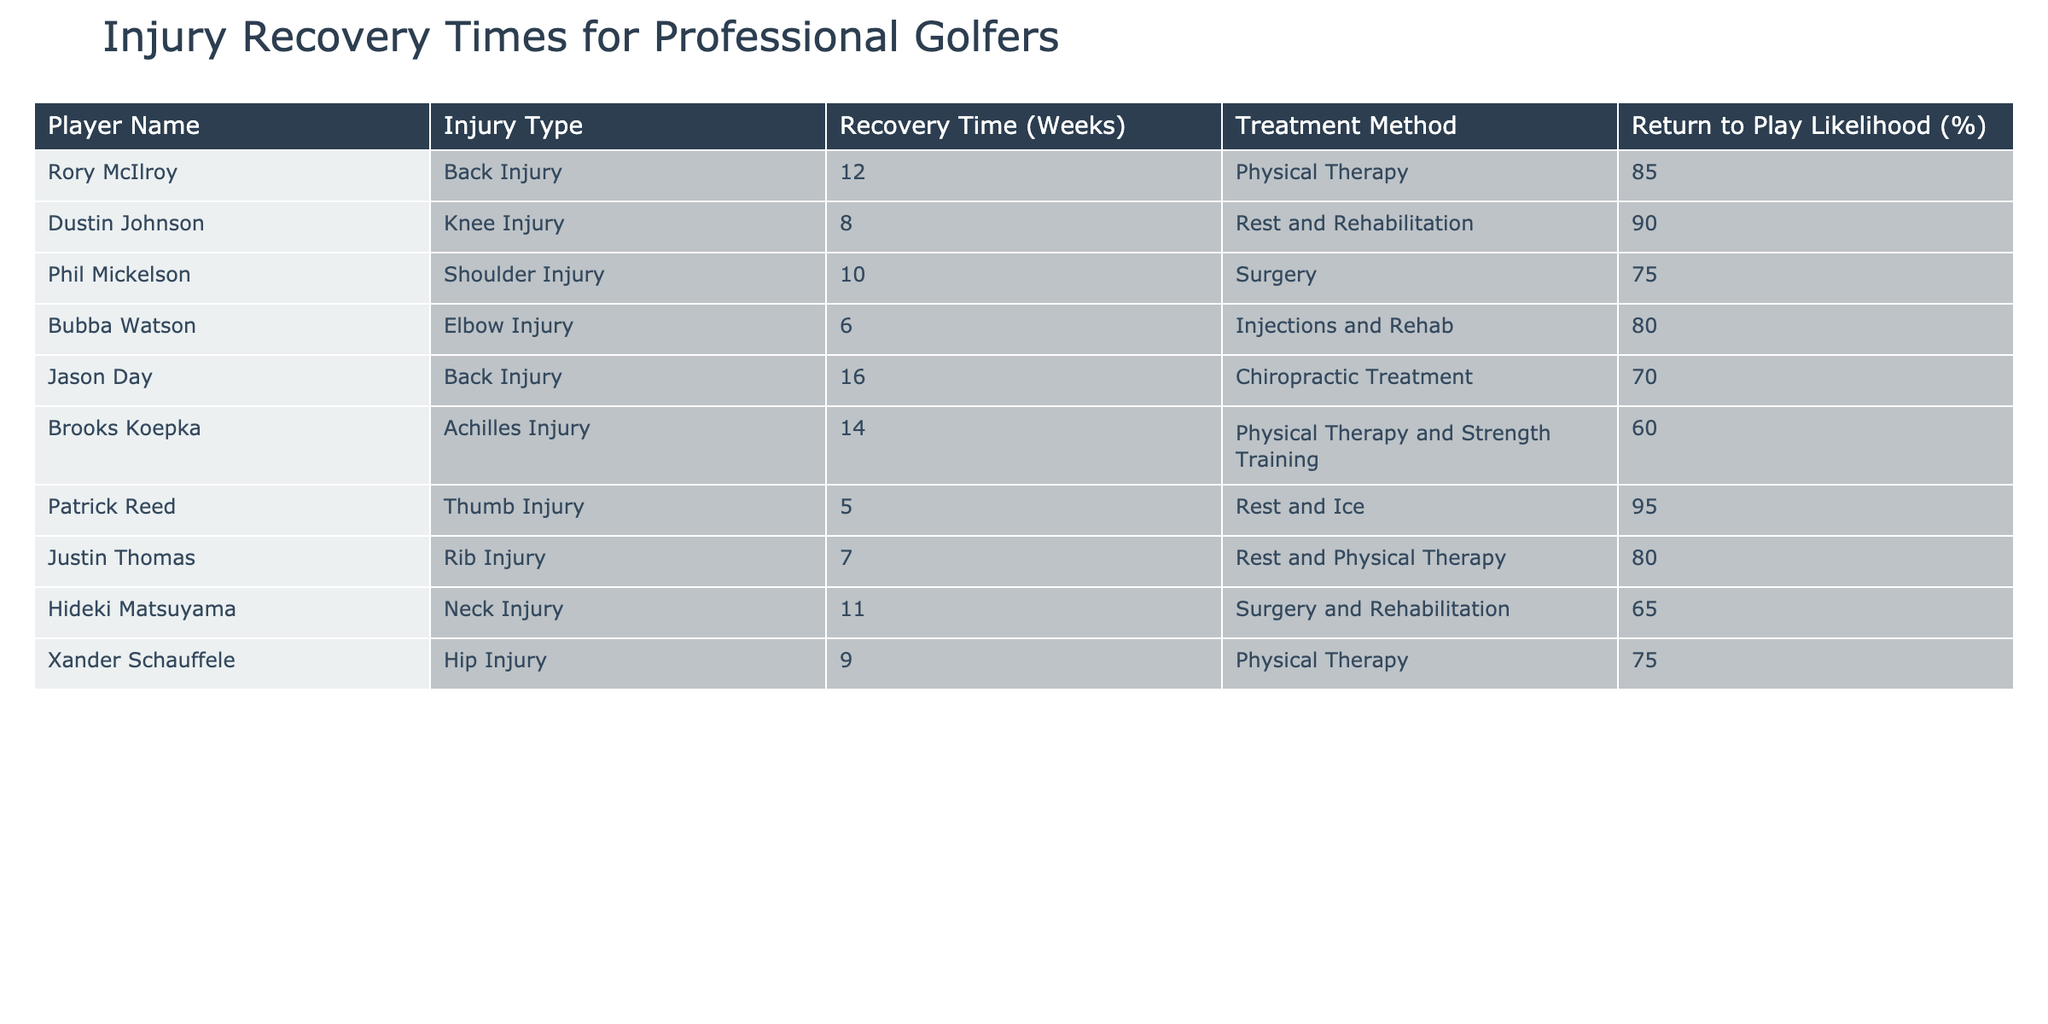What is the recovery time for Rory McIlroy? The table shows that Rory McIlroy has a recovery time of 12 weeks due to a back injury.
Answer: 12 weeks Which injury had the shortest recovery time? By comparing all recovery times listed in the table, the shortest recovery time is 5 weeks for Patrick Reed's thumb injury.
Answer: 5 weeks What is the likelihood of return to play for Jason Day? According to the table, Jason Day has a return to play likelihood of 70%.
Answer: 70% How many players implemented surgery as a treatment method? There are three players who underwent surgery: Phil Mickelson, Hideki Matsuyama, and one more player with a shoulder injury. Counting them gives us a total of 2.
Answer: 2 players What is the average recovery time for the players listed? First, we sum all the recovery times: 12 + 8 + 10 + 6 + 16 + 14 + 5 + 7 + 11 + 9 = 88 weeks. There are 10 players, so the average recovery time is 88/10 = 8.8 weeks.
Answer: 8.8 weeks Is it true that all injuries have a return to play likelihood of at least 60%? By checking each player's return to play likelihood, we find that Brooks Koepka has a likelihood of only 60%, while others are higher. Hence, it is true.
Answer: Yes Which type of injury has the longest recovery time and what is it? The longest recovery time in the table is 16 weeks for Jason Day, who has a back injury.
Answer: Back injury, 16 weeks Are there more players treating their injuries with physical therapy than with surgery? The table shows that four players are using physical therapy, whereas only two players are using surgery. Therefore, there are more players using physical therapy.
Answer: Yes What is the range of recovery times for the injuries listed? The recovery times range from the lowest of 5 weeks (Patrick Reed) to the highest of 16 weeks (Jason Day). Subtracting these gives a range of 16 - 5 = 11 weeks.
Answer: 11 weeks 